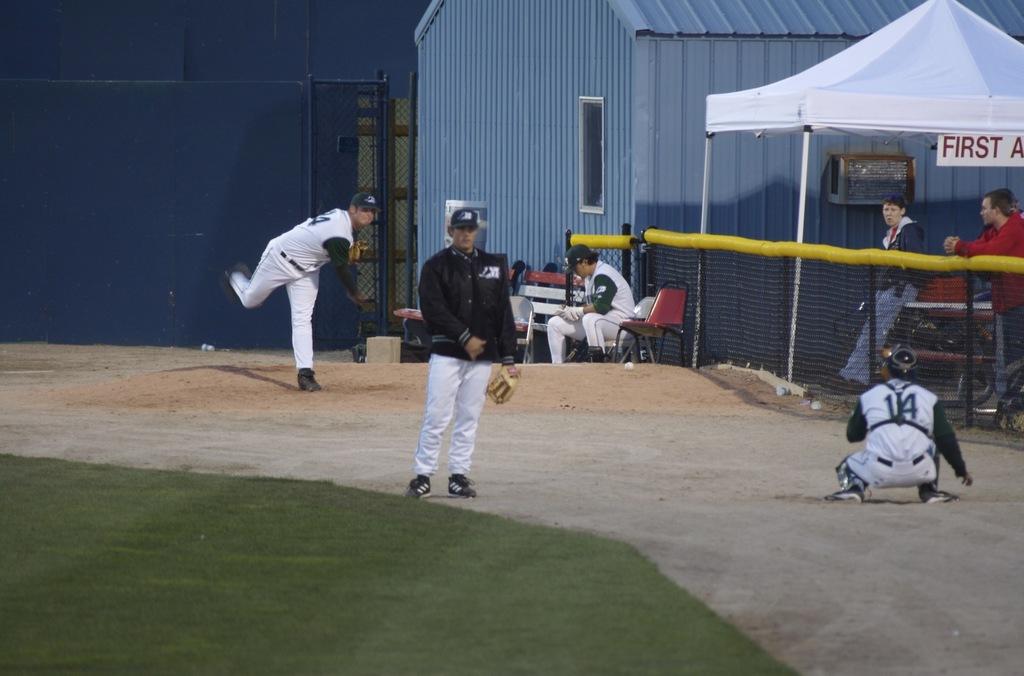What number is on the back of the catcher's jersey?
Offer a terse response. 14. 